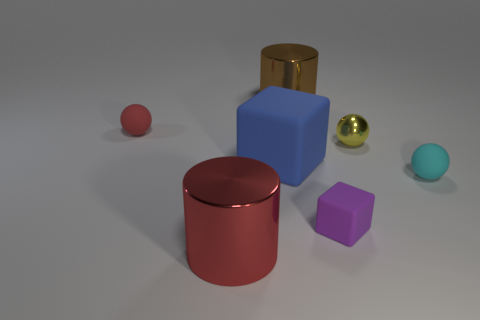What number of brown shiny cylinders have the same size as the blue block?
Give a very brief answer. 1. Do the red thing that is behind the big matte object and the block on the right side of the large brown metallic object have the same material?
Ensure brevity in your answer.  Yes. What material is the cylinder that is behind the small object that is left of the big blue block made of?
Provide a succinct answer. Metal. What material is the cube that is on the right side of the big brown cylinder?
Offer a terse response. Rubber. How many blue rubber things are the same shape as the purple object?
Make the answer very short. 1. What is the big cylinder behind the matte ball in front of the matte cube behind the small purple matte thing made of?
Provide a succinct answer. Metal. There is a brown thing; are there any matte things on the right side of it?
Ensure brevity in your answer.  Yes. There is another metallic object that is the same size as the cyan thing; what shape is it?
Your answer should be very brief. Sphere. Do the cyan ball and the large red object have the same material?
Offer a very short reply. No. What number of matte objects are large brown cubes or tiny spheres?
Provide a short and direct response. 2. 